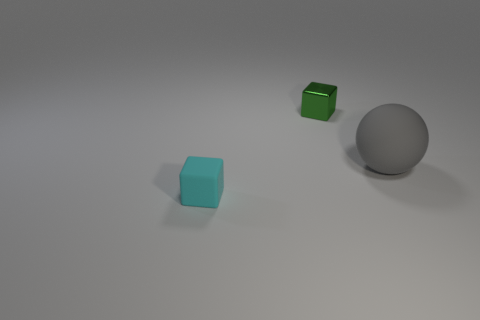What number of other green objects are the same shape as the tiny metal thing?
Give a very brief answer. 0. The rubber thing that is left of the matte object that is behind the tiny block in front of the green block is what color?
Your response must be concise. Cyan. Does the thing in front of the gray sphere have the same material as the block that is behind the big matte ball?
Keep it short and to the point. No. What number of things are small things that are behind the big gray object or small red matte cylinders?
Make the answer very short. 1. What number of objects are either large gray matte balls or small things that are to the right of the cyan block?
Offer a very short reply. 2. How many gray objects are the same size as the rubber ball?
Offer a very short reply. 0. Are there fewer large gray things that are in front of the big rubber thing than big gray rubber balls that are left of the shiny thing?
Ensure brevity in your answer.  No. How many metal objects are tiny gray spheres or tiny cubes?
Your answer should be compact. 1. What shape is the small rubber object?
Provide a succinct answer. Cube. There is a cyan thing that is the same size as the green metal cube; what material is it?
Give a very brief answer. Rubber. 